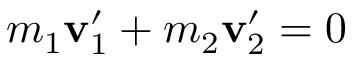<formula> <loc_0><loc_0><loc_500><loc_500>m _ { 1 } v _ { 1 } ^ { \prime } + m _ { 2 } v _ { 2 } ^ { \prime } = { 0 }</formula> 